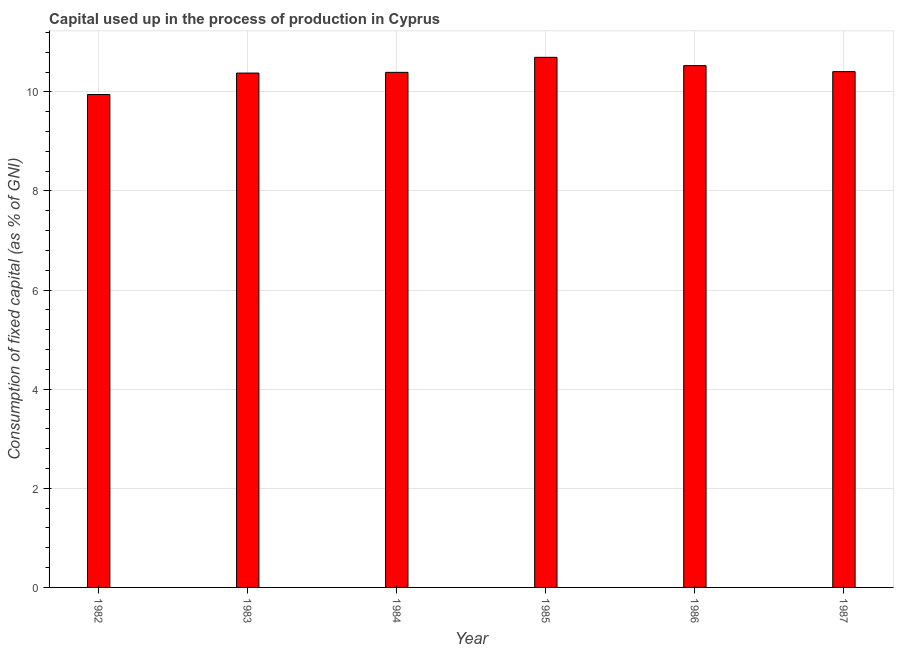Does the graph contain grids?
Ensure brevity in your answer.  Yes. What is the title of the graph?
Your answer should be compact. Capital used up in the process of production in Cyprus. What is the label or title of the Y-axis?
Keep it short and to the point. Consumption of fixed capital (as % of GNI). What is the consumption of fixed capital in 1983?
Provide a succinct answer. 10.38. Across all years, what is the maximum consumption of fixed capital?
Keep it short and to the point. 10.7. Across all years, what is the minimum consumption of fixed capital?
Your response must be concise. 9.95. In which year was the consumption of fixed capital maximum?
Offer a very short reply. 1985. In which year was the consumption of fixed capital minimum?
Provide a short and direct response. 1982. What is the sum of the consumption of fixed capital?
Your answer should be very brief. 62.35. What is the difference between the consumption of fixed capital in 1985 and 1986?
Your answer should be very brief. 0.17. What is the average consumption of fixed capital per year?
Your answer should be very brief. 10.39. What is the median consumption of fixed capital?
Your answer should be very brief. 10.4. What is the ratio of the consumption of fixed capital in 1986 to that in 1987?
Your answer should be very brief. 1.01. Is the consumption of fixed capital in 1984 less than that in 1985?
Give a very brief answer. Yes. Is the difference between the consumption of fixed capital in 1984 and 1987 greater than the difference between any two years?
Give a very brief answer. No. What is the difference between the highest and the second highest consumption of fixed capital?
Your response must be concise. 0.17. Is the sum of the consumption of fixed capital in 1983 and 1984 greater than the maximum consumption of fixed capital across all years?
Provide a short and direct response. Yes. What is the difference between the highest and the lowest consumption of fixed capital?
Make the answer very short. 0.75. In how many years, is the consumption of fixed capital greater than the average consumption of fixed capital taken over all years?
Keep it short and to the point. 4. Are all the bars in the graph horizontal?
Provide a succinct answer. No. What is the difference between two consecutive major ticks on the Y-axis?
Offer a very short reply. 2. Are the values on the major ticks of Y-axis written in scientific E-notation?
Ensure brevity in your answer.  No. What is the Consumption of fixed capital (as % of GNI) in 1982?
Your answer should be compact. 9.95. What is the Consumption of fixed capital (as % of GNI) in 1983?
Ensure brevity in your answer.  10.38. What is the Consumption of fixed capital (as % of GNI) of 1984?
Your answer should be compact. 10.39. What is the Consumption of fixed capital (as % of GNI) of 1985?
Give a very brief answer. 10.7. What is the Consumption of fixed capital (as % of GNI) of 1986?
Keep it short and to the point. 10.53. What is the Consumption of fixed capital (as % of GNI) of 1987?
Give a very brief answer. 10.41. What is the difference between the Consumption of fixed capital (as % of GNI) in 1982 and 1983?
Your answer should be very brief. -0.43. What is the difference between the Consumption of fixed capital (as % of GNI) in 1982 and 1984?
Provide a succinct answer. -0.45. What is the difference between the Consumption of fixed capital (as % of GNI) in 1982 and 1985?
Offer a terse response. -0.75. What is the difference between the Consumption of fixed capital (as % of GNI) in 1982 and 1986?
Your answer should be very brief. -0.58. What is the difference between the Consumption of fixed capital (as % of GNI) in 1982 and 1987?
Provide a succinct answer. -0.46. What is the difference between the Consumption of fixed capital (as % of GNI) in 1983 and 1984?
Keep it short and to the point. -0.01. What is the difference between the Consumption of fixed capital (as % of GNI) in 1983 and 1985?
Provide a short and direct response. -0.32. What is the difference between the Consumption of fixed capital (as % of GNI) in 1983 and 1986?
Ensure brevity in your answer.  -0.15. What is the difference between the Consumption of fixed capital (as % of GNI) in 1983 and 1987?
Your answer should be compact. -0.03. What is the difference between the Consumption of fixed capital (as % of GNI) in 1984 and 1985?
Offer a terse response. -0.3. What is the difference between the Consumption of fixed capital (as % of GNI) in 1984 and 1986?
Offer a very short reply. -0.14. What is the difference between the Consumption of fixed capital (as % of GNI) in 1984 and 1987?
Provide a short and direct response. -0.01. What is the difference between the Consumption of fixed capital (as % of GNI) in 1985 and 1986?
Your answer should be compact. 0.17. What is the difference between the Consumption of fixed capital (as % of GNI) in 1985 and 1987?
Offer a terse response. 0.29. What is the difference between the Consumption of fixed capital (as % of GNI) in 1986 and 1987?
Provide a short and direct response. 0.12. What is the ratio of the Consumption of fixed capital (as % of GNI) in 1982 to that in 1983?
Offer a terse response. 0.96. What is the ratio of the Consumption of fixed capital (as % of GNI) in 1982 to that in 1984?
Provide a short and direct response. 0.96. What is the ratio of the Consumption of fixed capital (as % of GNI) in 1982 to that in 1986?
Provide a succinct answer. 0.94. What is the ratio of the Consumption of fixed capital (as % of GNI) in 1982 to that in 1987?
Offer a very short reply. 0.96. What is the ratio of the Consumption of fixed capital (as % of GNI) in 1983 to that in 1985?
Your answer should be very brief. 0.97. What is the ratio of the Consumption of fixed capital (as % of GNI) in 1983 to that in 1986?
Your answer should be compact. 0.99. What is the ratio of the Consumption of fixed capital (as % of GNI) in 1984 to that in 1985?
Provide a succinct answer. 0.97. What is the ratio of the Consumption of fixed capital (as % of GNI) in 1984 to that in 1986?
Give a very brief answer. 0.99. What is the ratio of the Consumption of fixed capital (as % of GNI) in 1984 to that in 1987?
Your answer should be very brief. 1. What is the ratio of the Consumption of fixed capital (as % of GNI) in 1985 to that in 1987?
Offer a very short reply. 1.03. 